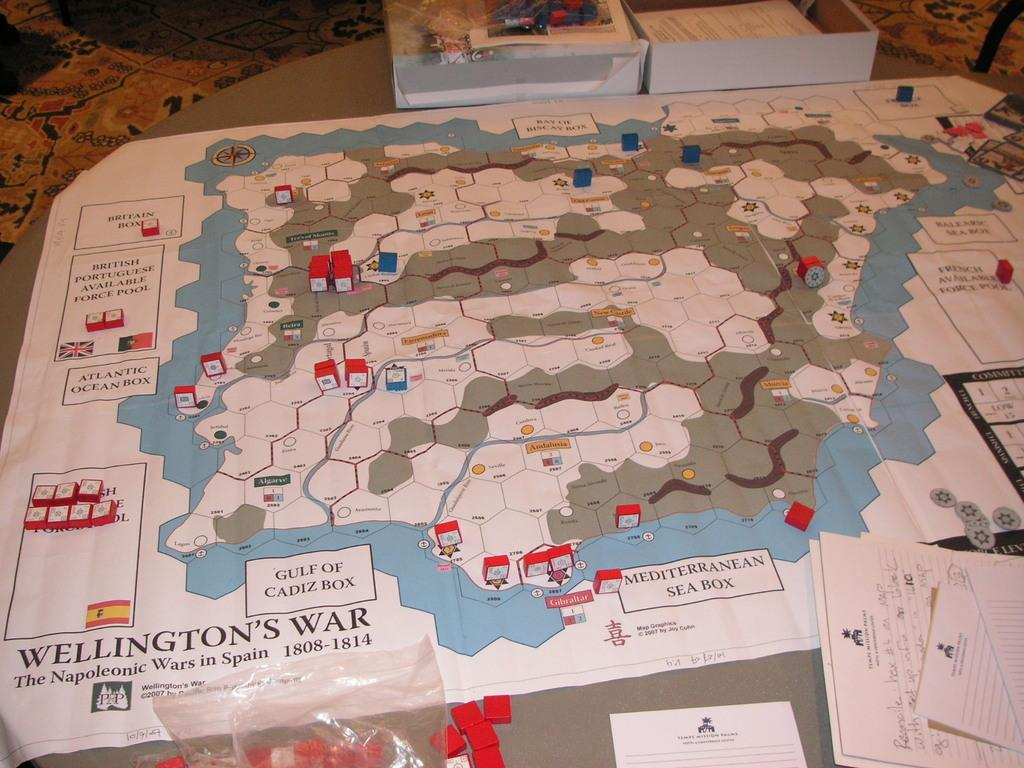<image>
Describe the image concisely. Map laid on table titled Wellingtons War from 1808 